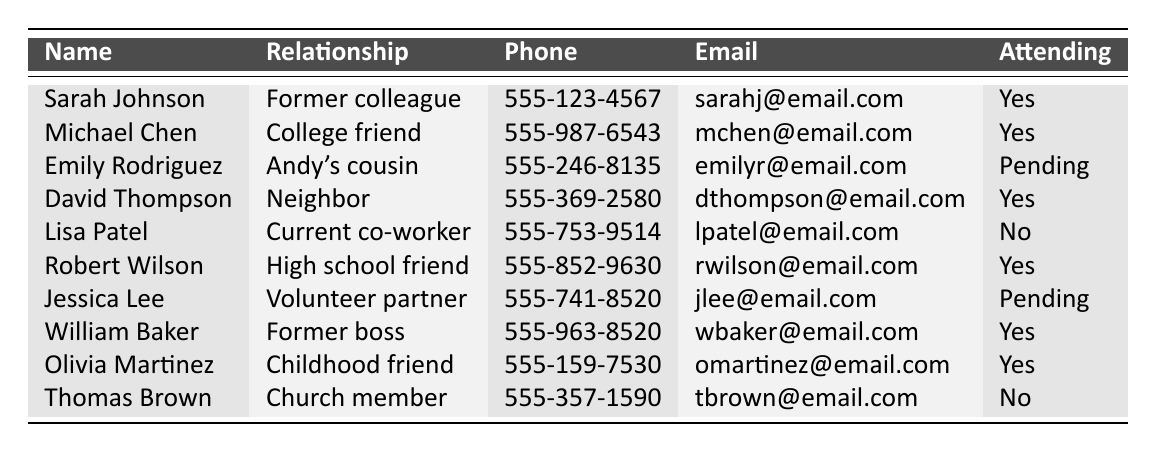What is the phone number of Sarah Johnson? Sarah Johnson's phone number is listed in the table. It can be found in the "Phone" column next to her name. The number is 555-123-4567.
Answer: 555-123-4567 How many people are confirmed to attend the memorial service? To determine the number of attendees, I count the entries under the "Attending" column that say "Yes." There are five people: Sarah Johnson, Michael Chen, David Thompson, Robert Wilson, William Baker, and Olivia Martinez.
Answer: 5 Is Jessica Lee attending the memorial service? Jessica Lee's entry in the "Attending" column is marked as "Pending." This indicates that she has not yet confirmed her attendance.
Answer: No How many former colleagues are attending the service? First, I find all entries with the relationship "Former colleague." There are two: Sarah Johnson and William Baker, both of whom are confirmed to attend (both marked "Yes" in the "Attending" column). Therefore, there are two former colleagues attending.
Answer: 2 What percentage of the attendees have a relationship with Andy that is family-related? I count the total number of attendees first, which is six (from those who responded "Yes"). Then, I find out how many of these are family. The only family-related entry is Emily Rodriguez who is Andy's cousin. So, the percentage is (1/6) × 100 = 16.67%.
Answer: 16.67% Which person has the email address 'lpatel@email.com'? The email address is present in the "Email" column. By looking at the table, I see that it belongs to Lisa Patel.
Answer: Lisa Patel Are there any childhood friends attending the service? I locate the entry for the relationship "Childhood friend." There is one person, Olivia Martinez, who is attending as confirmed by the "Yes" in the "Attending" column.
Answer: Yes Who has the highest number of years of known relationship with Andy listed? This requires some interpretation. Among the relationships, "Former colleague," "College friend," "High school friend," and others cover varying durations. Typically, former colleagues or family members like Andy's cousin would suggest a long-standing relationship. Emily Rodriguez (Andy's cousin) implies a lifelong relationship, which is typically longer than the friendship categories.
Answer: Emily Rodriguez List the names of those who are not attending the service. I will check the "Attending" column for "No." The two entries are Lisa Patel and Thomas Brown, so their names are the only ones not attending.
Answer: Lisa Patel, Thomas Brown 